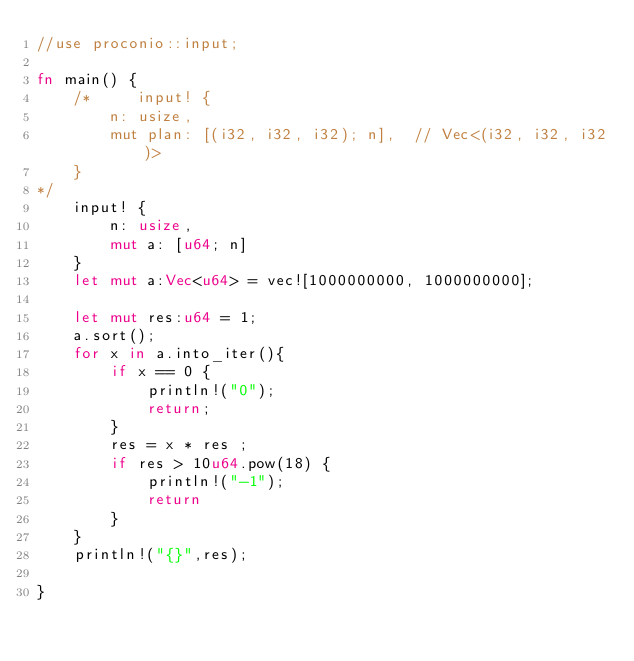Convert code to text. <code><loc_0><loc_0><loc_500><loc_500><_Rust_>//use proconio::input;

fn main() {
    /*     input! {
        n: usize,
        mut plan: [(i32, i32, i32); n],  // Vec<(i32, i32, i32)>
    }
*/
    input! {
        n: usize,
        mut a: [u64; n]
    }
    let mut a:Vec<u64> = vec![1000000000, 1000000000];

    let mut res:u64 = 1;
    a.sort();
    for x in a.into_iter(){
        if x == 0 {
            println!("0");
            return;
        }
        res = x * res ;
        if res > 10u64.pow(18) {
            println!("-1");
            return
        } 
    }
    println!("{}",res);

}  </code> 